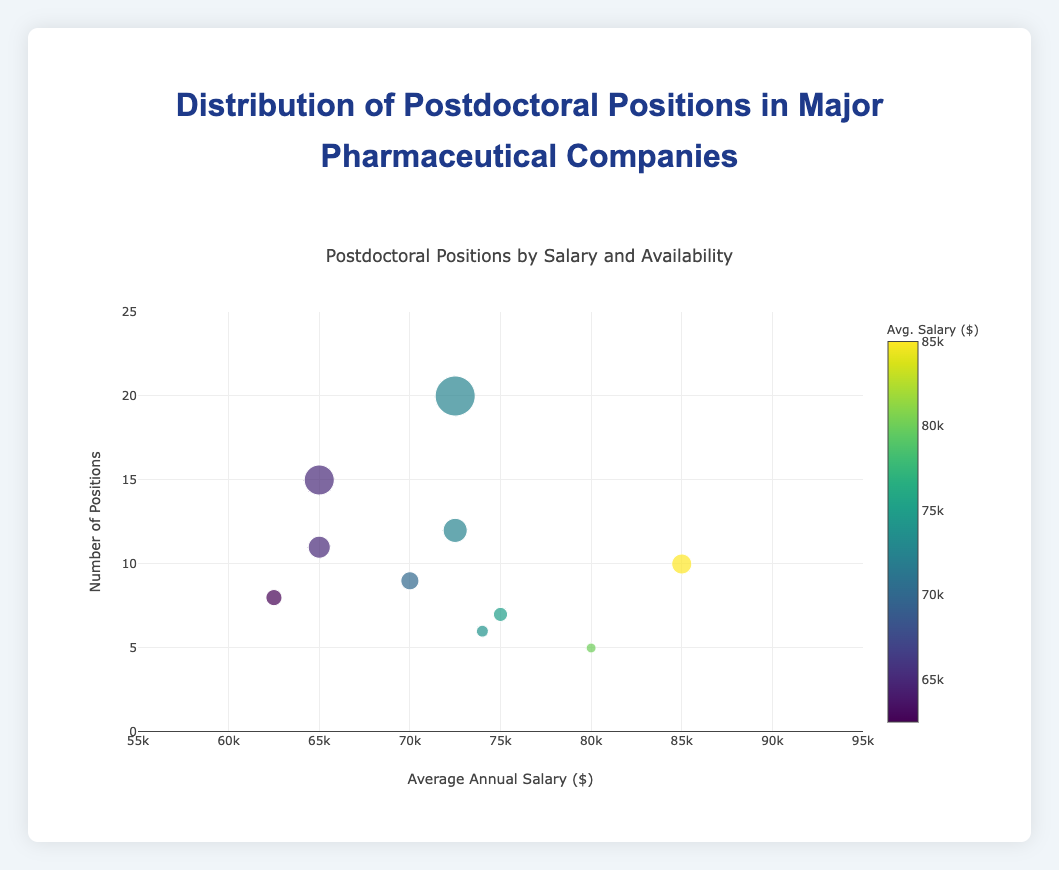What is the title of the figure? The title of the figure is displayed at the top in larger and bold font. It is clearly labeled.
Answer: Postdoctoral Positions by Salary and Availability How many companies offer postdoctoral positions with an average annual salary above $80,000? By observing the x-axis, find the data points above the $80,000 mark, then count these data points. We see two such points, which correspond to Roche and AstraZeneca.
Answer: 2 Which company has the highest number of postdoctoral positions? Look for the maximum value on the y-axis and find which data point reaches this value. Novartis has 20 positions, the highest on the y-axis.
Answer: Novartis What is the average annual salary range for Pfizer's postdoctoral positions? Hovering over the data point corresponding to Pfizer located in New York, USA, the label shows the salary range.
Answer: $60,000-$70,000 Which location offers postdoctoral positions with the lowest average annual salary? Identify the minimum value on the x-axis where the average annual salary is the lowest. The data indicates this is for GlaxoSmithKline in London, UK, with an average salary around $62,500
Answer: London, UK Compare the number of postdoctoral positions between Sanofi and Eli Lilly. Locate the data points for Sanofi and Eli Lilly on the y-axis to compare their positions. Sanofi has 12 positions while Eli Lilly has 6. Calculating the difference, Sanofi has 6 more positions.
Answer: Sanofi has 6 more positions than Eli Lilly What color represents the highest average annual salary on the color bar? The color bar on the right indicates the scale. The highest value ($90,000) corresponds to the lightest color on the bar.
Answer: Lightest color How many companies have postdoctoral positions with an average annual salary between $70,000 and $80,000? Identify the range on the x-axis between 70,000 and 80,000, and count the number of data points. The companies are Sanofi, Johnson & Johnson, and Eli Lilly.
Answer: 3 What is the geographical location for the company with the smallest number of postdoctoral positions? Look for the smallest value on the y-axis, which corresponds to AstraZeneca. Check the text label to find the location, Gothenburg, Sweden.
Answer: Gothenburg, Sweden Which company based in the USA has the lowest average annual salary for postdoctoral positions? Filter out only companies based in the USA and compare their average annual salaries on the x-axis. Pfizer and AbbVie both show the lowest average around $65,000 among the USA-based companies.
Answer: Pfizer and AbbVie 